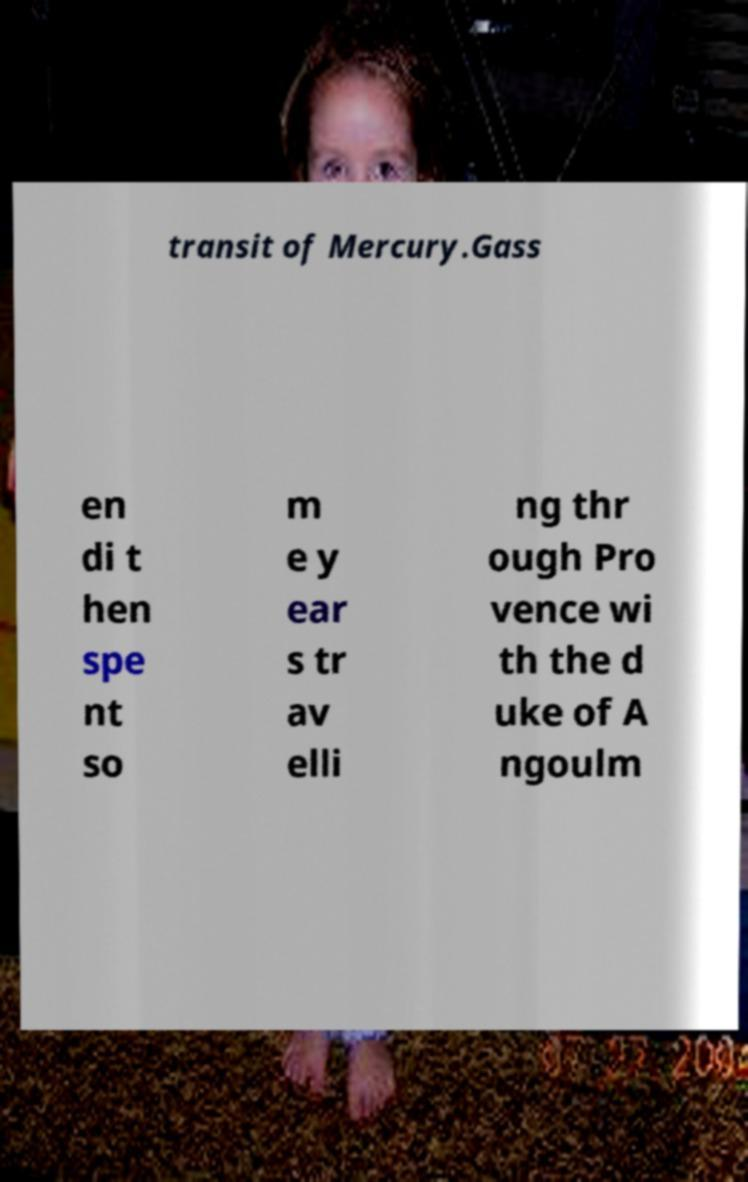Could you extract and type out the text from this image? transit of Mercury.Gass en di t hen spe nt so m e y ear s tr av elli ng thr ough Pro vence wi th the d uke of A ngoulm 